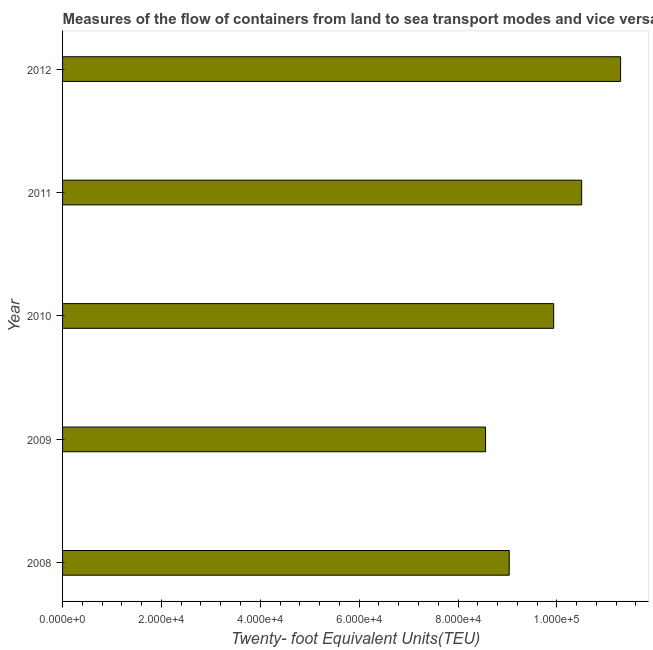What is the title of the graph?
Provide a succinct answer. Measures of the flow of containers from land to sea transport modes and vice versa in Brunei Darussalam. What is the label or title of the X-axis?
Offer a terse response. Twenty- foot Equivalent Units(TEU). What is the container port traffic in 2008?
Ensure brevity in your answer.  9.04e+04. Across all years, what is the maximum container port traffic?
Keep it short and to the point. 1.13e+05. Across all years, what is the minimum container port traffic?
Offer a terse response. 8.56e+04. In which year was the container port traffic maximum?
Provide a short and direct response. 2012. What is the sum of the container port traffic?
Offer a terse response. 4.93e+05. What is the difference between the container port traffic in 2011 and 2012?
Your response must be concise. -7876.36. What is the average container port traffic per year?
Offer a terse response. 9.86e+04. What is the median container port traffic?
Your answer should be very brief. 9.94e+04. What is the ratio of the container port traffic in 2009 to that in 2011?
Provide a succinct answer. 0.81. What is the difference between the highest and the second highest container port traffic?
Ensure brevity in your answer.  7876.36. Is the sum of the container port traffic in 2008 and 2009 greater than the maximum container port traffic across all years?
Your response must be concise. Yes. What is the difference between the highest and the lowest container port traffic?
Your answer should be compact. 2.73e+04. In how many years, is the container port traffic greater than the average container port traffic taken over all years?
Your response must be concise. 3. What is the Twenty- foot Equivalent Units(TEU) of 2008?
Your answer should be compact. 9.04e+04. What is the Twenty- foot Equivalent Units(TEU) in 2009?
Offer a terse response. 8.56e+04. What is the Twenty- foot Equivalent Units(TEU) of 2010?
Provide a succinct answer. 9.94e+04. What is the Twenty- foot Equivalent Units(TEU) of 2011?
Your answer should be compact. 1.05e+05. What is the Twenty- foot Equivalent Units(TEU) of 2012?
Make the answer very short. 1.13e+05. What is the difference between the Twenty- foot Equivalent Units(TEU) in 2008 and 2009?
Give a very brief answer. 4789. What is the difference between the Twenty- foot Equivalent Units(TEU) in 2008 and 2010?
Provide a short and direct response. -8988.9. What is the difference between the Twenty- foot Equivalent Units(TEU) in 2008 and 2011?
Provide a succinct answer. -1.47e+04. What is the difference between the Twenty- foot Equivalent Units(TEU) in 2008 and 2012?
Offer a very short reply. -2.25e+04. What is the difference between the Twenty- foot Equivalent Units(TEU) in 2009 and 2010?
Provide a succinct answer. -1.38e+04. What is the difference between the Twenty- foot Equivalent Units(TEU) in 2009 and 2011?
Ensure brevity in your answer.  -1.94e+04. What is the difference between the Twenty- foot Equivalent Units(TEU) in 2009 and 2012?
Provide a succinct answer. -2.73e+04. What is the difference between the Twenty- foot Equivalent Units(TEU) in 2010 and 2011?
Keep it short and to the point. -5663.23. What is the difference between the Twenty- foot Equivalent Units(TEU) in 2010 and 2012?
Offer a terse response. -1.35e+04. What is the difference between the Twenty- foot Equivalent Units(TEU) in 2011 and 2012?
Your answer should be very brief. -7876.36. What is the ratio of the Twenty- foot Equivalent Units(TEU) in 2008 to that in 2009?
Offer a very short reply. 1.06. What is the ratio of the Twenty- foot Equivalent Units(TEU) in 2008 to that in 2010?
Your answer should be compact. 0.91. What is the ratio of the Twenty- foot Equivalent Units(TEU) in 2008 to that in 2011?
Give a very brief answer. 0.86. What is the ratio of the Twenty- foot Equivalent Units(TEU) in 2009 to that in 2010?
Ensure brevity in your answer.  0.86. What is the ratio of the Twenty- foot Equivalent Units(TEU) in 2009 to that in 2011?
Keep it short and to the point. 0.81. What is the ratio of the Twenty- foot Equivalent Units(TEU) in 2009 to that in 2012?
Offer a terse response. 0.76. What is the ratio of the Twenty- foot Equivalent Units(TEU) in 2010 to that in 2011?
Offer a very short reply. 0.95. What is the ratio of the Twenty- foot Equivalent Units(TEU) in 2011 to that in 2012?
Keep it short and to the point. 0.93. 